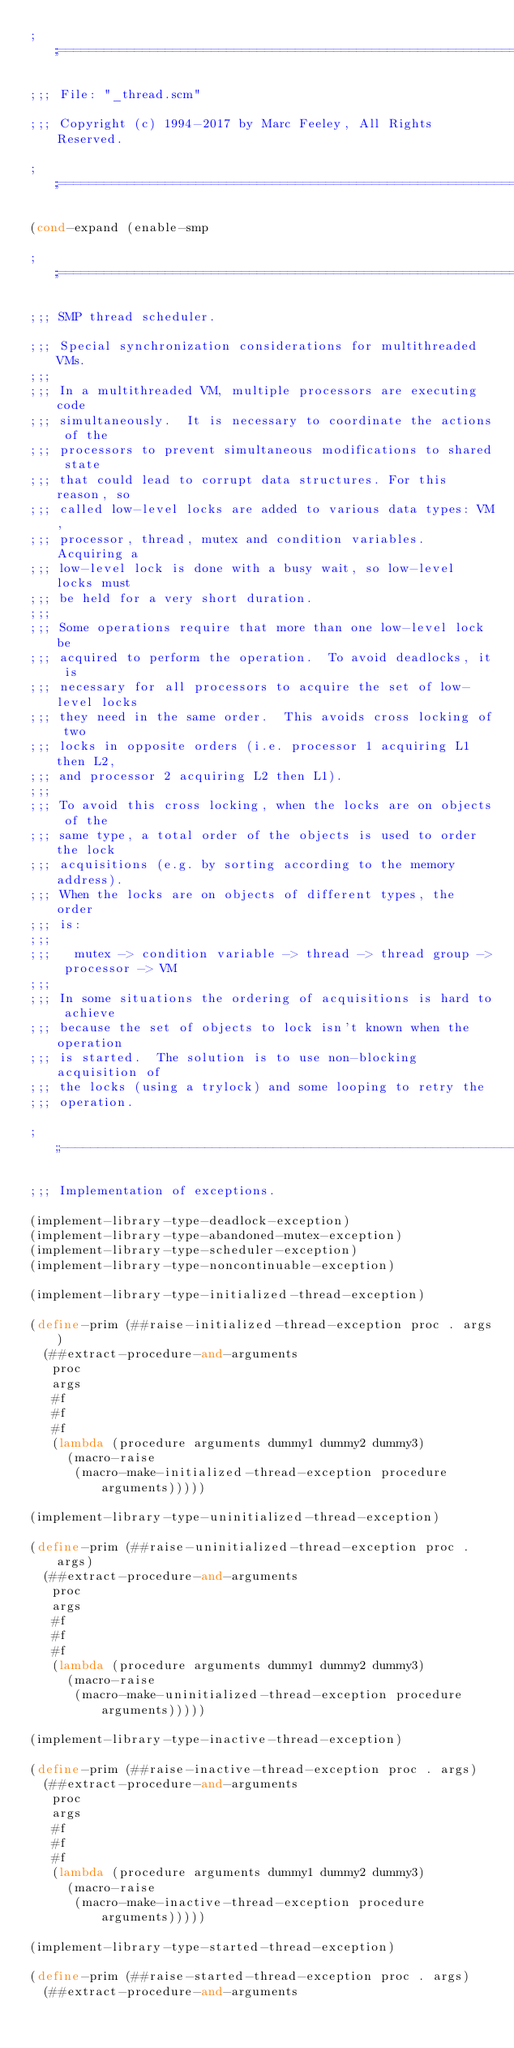Convert code to text. <code><loc_0><loc_0><loc_500><loc_500><_Scheme_>;;;============================================================================

;;; File: "_thread.scm"

;;; Copyright (c) 1994-2017 by Marc Feeley, All Rights Reserved.

;;;============================================================================

(cond-expand (enable-smp

;;;============================================================================

;;; SMP thread scheduler.

;;; Special synchronization considerations for multithreaded VMs.
;;;
;;; In a multithreaded VM, multiple processors are executing code
;;; simultaneously.  It is necessary to coordinate the actions of the
;;; processors to prevent simultaneous modifications to shared state
;;; that could lead to corrupt data structures. For this reason, so
;;; called low-level locks are added to various data types: VM,
;;; processor, thread, mutex and condition variables. Acquiring a
;;; low-level lock is done with a busy wait, so low-level locks must
;;; be held for a very short duration.
;;;
;;; Some operations require that more than one low-level lock be
;;; acquired to perform the operation.  To avoid deadlocks, it is
;;; necessary for all processors to acquire the set of low-level locks
;;; they need in the same order.  This avoids cross locking of two
;;; locks in opposite orders (i.e. processor 1 acquiring L1 then L2,
;;; and processor 2 acquiring L2 then L1).
;;;
;;; To avoid this cross locking, when the locks are on objects of the
;;; same type, a total order of the objects is used to order the lock
;;; acquisitions (e.g. by sorting according to the memory address).
;;; When the locks are on objects of different types, the order
;;; is:
;;;
;;;   mutex -> condition variable -> thread -> thread group -> processor -> VM
;;;
;;; In some situations the ordering of acquisitions is hard to achieve
;;; because the set of objects to lock isn't known when the operation
;;; is started.  The solution is to use non-blocking acquisition of
;;; the locks (using a trylock) and some looping to retry the
;;; operation.

;;;----------------------------------------------------------------------------

;;; Implementation of exceptions.

(implement-library-type-deadlock-exception)
(implement-library-type-abandoned-mutex-exception)
(implement-library-type-scheduler-exception)
(implement-library-type-noncontinuable-exception)

(implement-library-type-initialized-thread-exception)

(define-prim (##raise-initialized-thread-exception proc . args)
  (##extract-procedure-and-arguments
   proc
   args
   #f
   #f
   #f
   (lambda (procedure arguments dummy1 dummy2 dummy3)
     (macro-raise
      (macro-make-initialized-thread-exception procedure arguments)))))

(implement-library-type-uninitialized-thread-exception)

(define-prim (##raise-uninitialized-thread-exception proc . args)
  (##extract-procedure-and-arguments
   proc
   args
   #f
   #f
   #f
   (lambda (procedure arguments dummy1 dummy2 dummy3)
     (macro-raise
      (macro-make-uninitialized-thread-exception procedure arguments)))))

(implement-library-type-inactive-thread-exception)

(define-prim (##raise-inactive-thread-exception proc . args)
  (##extract-procedure-and-arguments
   proc
   args
   #f
   #f
   #f
   (lambda (procedure arguments dummy1 dummy2 dummy3)
     (macro-raise
      (macro-make-inactive-thread-exception procedure arguments)))))

(implement-library-type-started-thread-exception)

(define-prim (##raise-started-thread-exception proc . args)
  (##extract-procedure-and-arguments</code> 